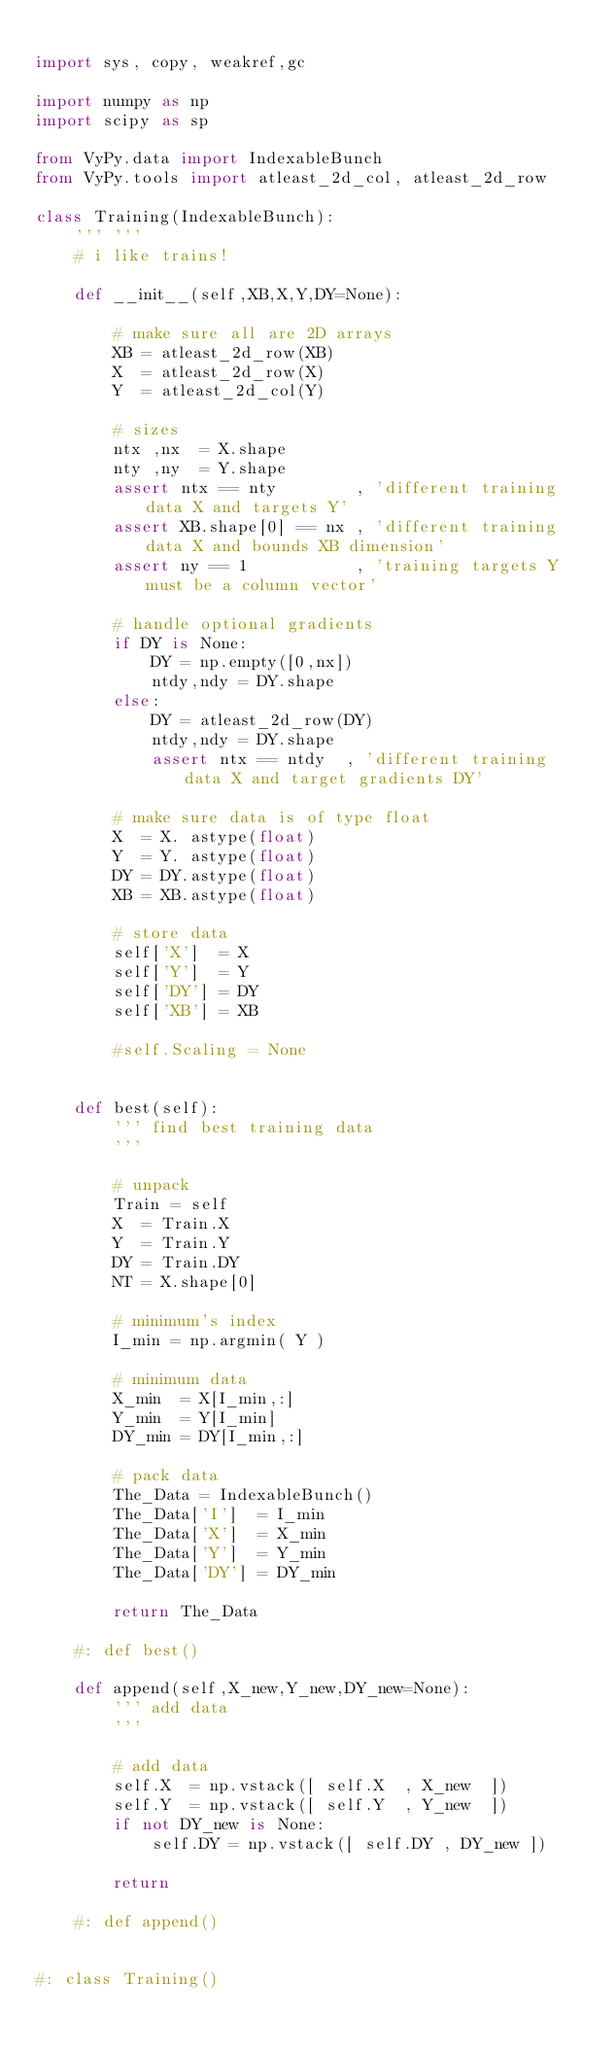Convert code to text. <code><loc_0><loc_0><loc_500><loc_500><_Python_>
import sys, copy, weakref,gc

import numpy as np
import scipy as sp

from VyPy.data import IndexableBunch
from VyPy.tools import atleast_2d_col, atleast_2d_row

class Training(IndexableBunch):  
    ''' '''
    # i like trains!
    
    def __init__(self,XB,X,Y,DY=None):
        
        # make sure all are 2D arrays
        XB = atleast_2d_row(XB)
        X  = atleast_2d_row(X)
        Y  = atleast_2d_col(Y)
        
        # sizes
        ntx ,nx  = X.shape
        nty ,ny  = Y.shape
        assert ntx == nty        , 'different training data X and targets Y'
        assert XB.shape[0] == nx , 'different training data X and bounds XB dimension'
        assert ny == 1           , 'training targets Y must be a column vector'
        
        # handle optional gradients
        if DY is None:
            DY = np.empty([0,nx])
            ntdy,ndy = DY.shape
        else:
            DY = atleast_2d_row(DY)
            ntdy,ndy = DY.shape
            assert ntx == ntdy  , 'different training data X and target gradients DY'
            
        # make sure data is of type float
        X  = X. astype(float)
        Y  = Y. astype(float)
        DY = DY.astype(float)
        XB = XB.astype(float)
    
        # store data
        self['X']  = X
        self['Y']  = Y
        self['DY'] = DY
        self['XB'] = XB
        
        #self.Scaling = None
        

    def best(self):
        ''' find best training data
        '''
        
        # unpack
        Train = self
        X  = Train.X
        Y  = Train.Y
        DY = Train.DY
        NT = X.shape[0]
        
        # minimum's index
        I_min = np.argmin( Y )
        
        # minimum data
        X_min  = X[I_min,:]
        Y_min  = Y[I_min]
        DY_min = DY[I_min,:]
        
        # pack data
        The_Data = IndexableBunch()
        The_Data['I']  = I_min
        The_Data['X']  = X_min
        The_Data['Y']  = Y_min
        The_Data['DY'] = DY_min
            
        return The_Data
    
    #: def best()
    
    def append(self,X_new,Y_new,DY_new=None):
        ''' add data
        '''
        
        # add data
        self.X  = np.vstack([ self.X  , X_new  ])
        self.Y  = np.vstack([ self.Y  , Y_new  ])
        if not DY_new is None:
            self.DY = np.vstack([ self.DY , DY_new ])
        
        return
    
    #: def append()
    

#: class Training()
</code> 